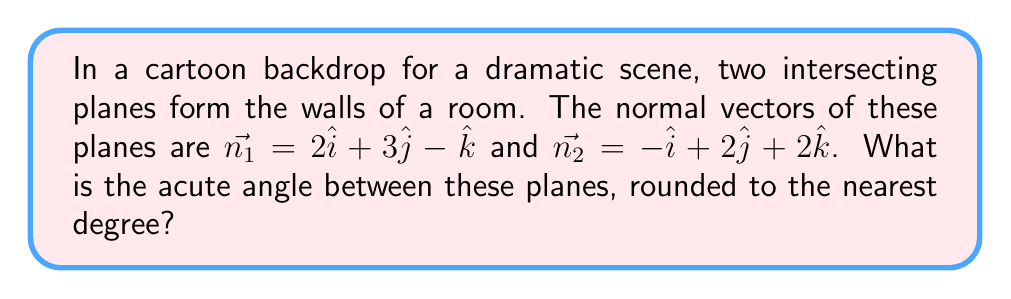Give your solution to this math problem. To find the angle between two intersecting planes, we can use the dot product of their normal vectors. The steps are as follows:

1) The formula for the angle $\theta$ between two planes with normal vectors $\vec{n_1}$ and $\vec{n_2}$ is:

   $$\cos\theta = \frac{|\vec{n_1} \cdot \vec{n_2}|}{\|\vec{n_1}\| \|\vec{n_2}\|}$$

2) Calculate the dot product $\vec{n_1} \cdot \vec{n_2}$:
   $$(2\hat{i} + 3\hat{j} - \hat{k}) \cdot (-\hat{i} + 2\hat{j} + 2\hat{k}) = -2 + 6 - 2 = 2$$

3) Calculate the magnitudes of the normal vectors:
   $$\|\vec{n_1}\| = \sqrt{2^2 + 3^2 + (-1)^2} = \sqrt{14}$$
   $$\|\vec{n_2}\| = \sqrt{(-1)^2 + 2^2 + 2^2} = 3$$

4) Substitute into the formula:
   $$\cos\theta = \frac{|2|}{\sqrt{14} \cdot 3} = \frac{2}{3\sqrt{14}}$$

5) Take the inverse cosine (arccos) of both sides:
   $$\theta = \arccos(\frac{2}{3\sqrt{14}})$$

6) Calculate and round to the nearest degree:
   $$\theta \approx 80°$$
Answer: 80° 